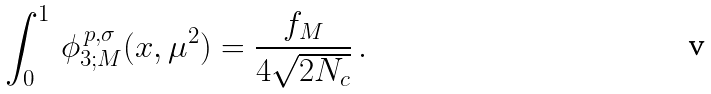<formula> <loc_0><loc_0><loc_500><loc_500>\int ^ { 1 } _ { 0 } \, \phi ^ { \, p , \sigma } _ { 3 ; M } ( x , \mu ^ { 2 } ) = \frac { f _ { M } } { 4 \sqrt { 2 N _ { c } } } \, .</formula> 